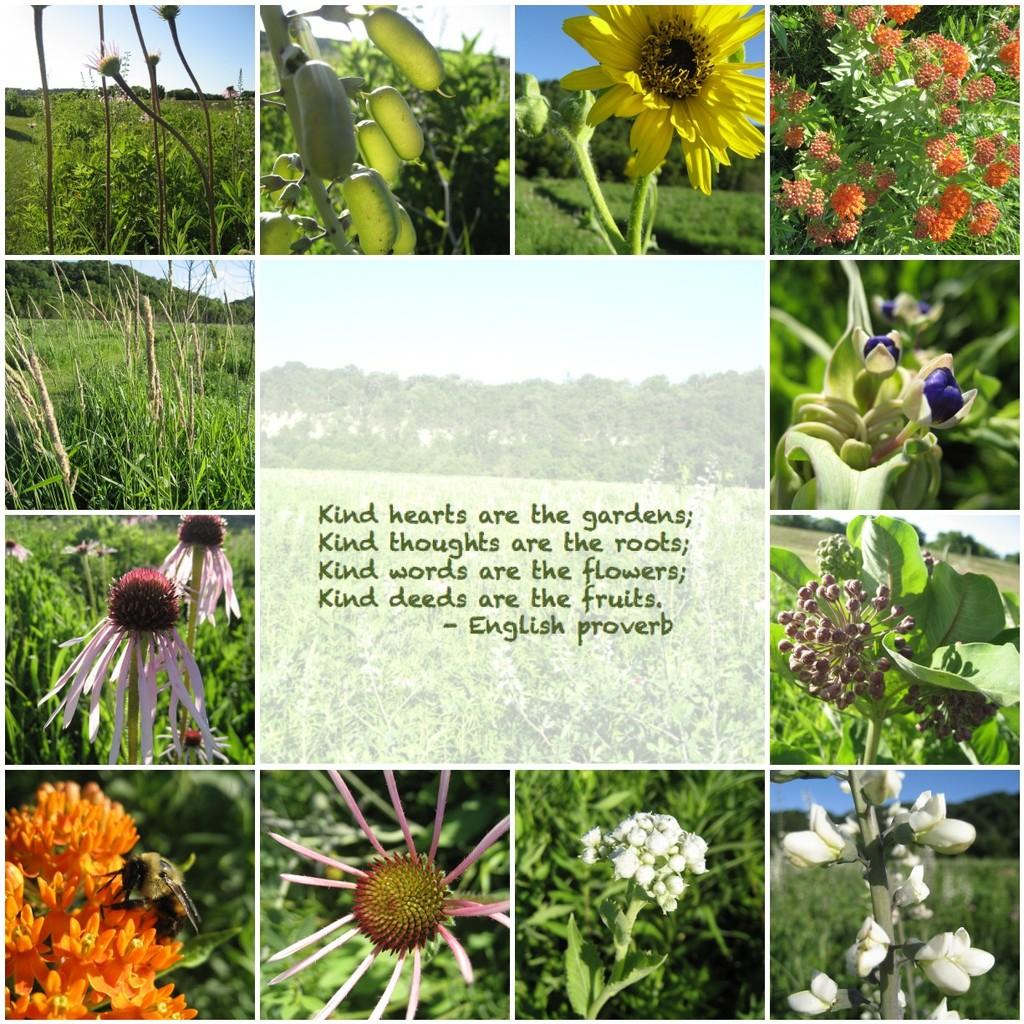What type of images are present in the collage in the image? The collage pictures in the image contain plants and flowers. Is there any text present in the image? Yes, there is text in the center of the image. How many hands are visible in the image? There are no hands visible in the image; it contains a collage of plants and flowers with text in the center. 